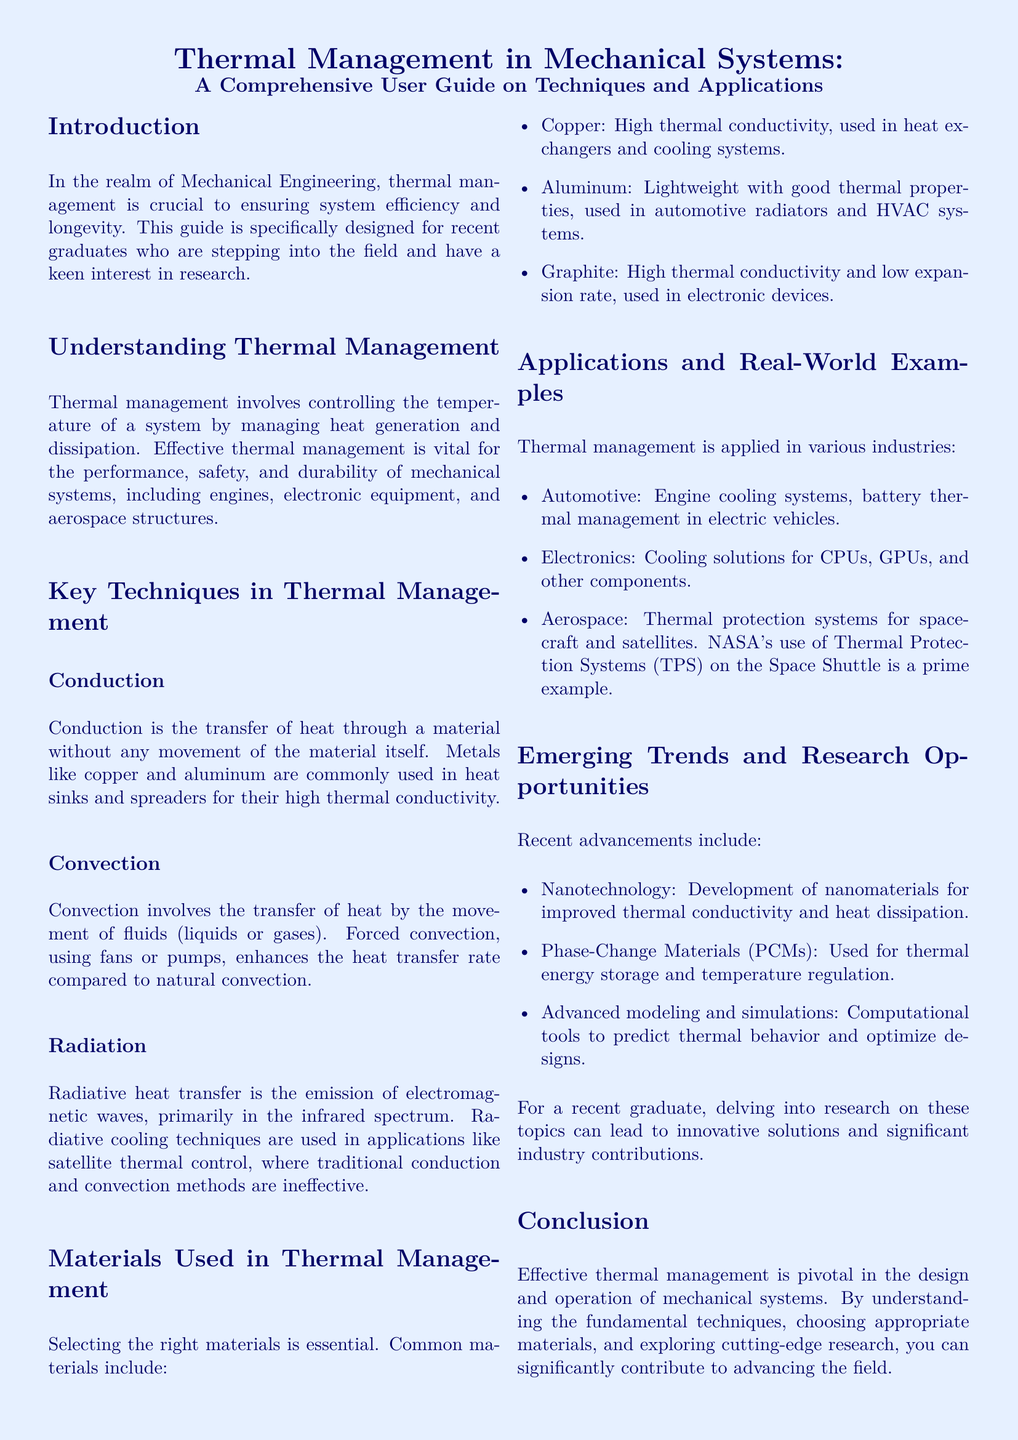What is the primary focus of the guide? The primary focus of the guide is on thermal management in mechanical systems, particularly for recent graduates interested in research.
Answer: Thermal management in mechanical systems What materials are commonly used in thermal management? The document lists common materials used in thermal management, including copper, aluminum, and graphite.
Answer: Copper, aluminum, graphite What technique enhances heat transfer rate compared to natural convection? The document specifies that forced convection, using fans or pumps, enhances the heat transfer rate compared to natural convection.
Answer: Forced convection Which industry applies thermal management for engine cooling systems? The document mentions that thermal management is applied in the automotive industry for engine cooling systems.
Answer: Automotive What advanced technology is mentioned for temperature regulation? The guide discusses Phase-Change Materials (PCMs) as an advanced technology used for thermal energy storage and temperature regulation.
Answer: Phase-Change Materials (PCMs) What role does nanotechnology play according to the guide? The guide states that nanotechnology contributes to the development of nanomaterials for improved thermal conductivity and heat dissipation.
Answer: Improved thermal conductivity What is an example of thermal management in aerospace? The guide provides NASA's use of Thermal Protection Systems (TPS) on the Space Shuttle as an example of thermal management in aerospace.
Answer: Thermal Protection Systems (TPS) What is the significance of effective thermal management? The document emphasizes that effective thermal management is pivotal for the design and operation of mechanical systems.
Answer: Pivotal for design and operation What is the target audience of this user guide? The user guide is specifically designed for recent graduates who are stepping into the field of mechanical engineering.
Answer: Recent graduates 